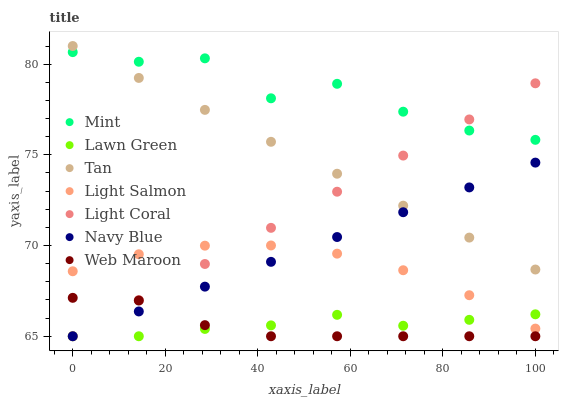Does Web Maroon have the minimum area under the curve?
Answer yes or no. Yes. Does Mint have the maximum area under the curve?
Answer yes or no. Yes. Does Light Salmon have the minimum area under the curve?
Answer yes or no. No. Does Light Salmon have the maximum area under the curve?
Answer yes or no. No. Is Light Coral the smoothest?
Answer yes or no. Yes. Is Mint the roughest?
Answer yes or no. Yes. Is Light Salmon the smoothest?
Answer yes or no. No. Is Light Salmon the roughest?
Answer yes or no. No. Does Lawn Green have the lowest value?
Answer yes or no. Yes. Does Light Salmon have the lowest value?
Answer yes or no. No. Does Tan have the highest value?
Answer yes or no. Yes. Does Light Salmon have the highest value?
Answer yes or no. No. Is Light Salmon less than Tan?
Answer yes or no. Yes. Is Mint greater than Navy Blue?
Answer yes or no. Yes. Does Light Coral intersect Web Maroon?
Answer yes or no. Yes. Is Light Coral less than Web Maroon?
Answer yes or no. No. Is Light Coral greater than Web Maroon?
Answer yes or no. No. Does Light Salmon intersect Tan?
Answer yes or no. No. 